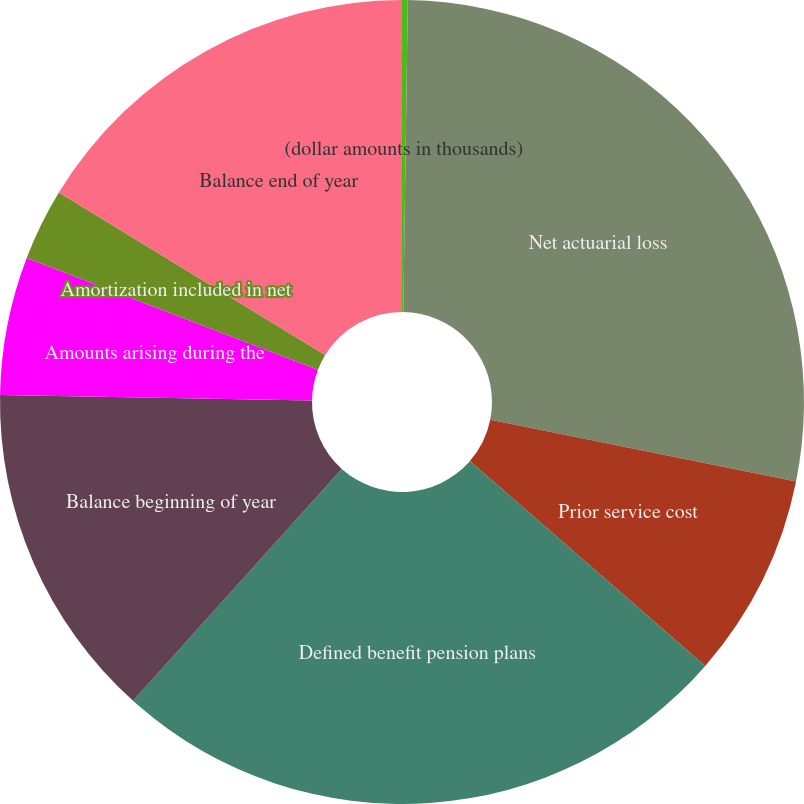Convert chart to OTSL. <chart><loc_0><loc_0><loc_500><loc_500><pie_chart><fcel>(dollar amounts in thousands)<fcel>Net actuarial loss<fcel>Prior service cost<fcel>Defined benefit pension plans<fcel>Balance beginning of year<fcel>Amounts arising during the<fcel>Amortization included in net<fcel>Balance end of year<nl><fcel>0.23%<fcel>27.94%<fcel>8.23%<fcel>25.27%<fcel>13.61%<fcel>5.56%<fcel>2.89%<fcel>16.28%<nl></chart> 